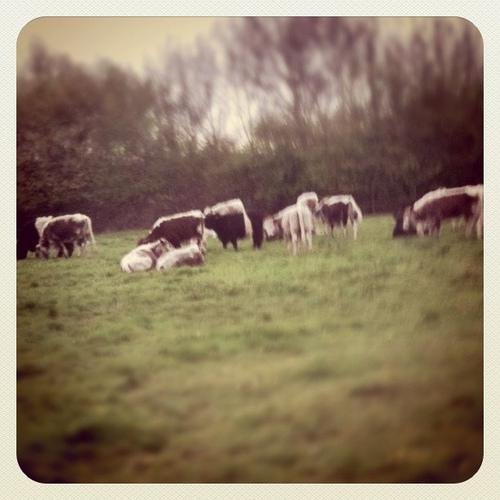Question: what is the main subject of this picture?
Choices:
A. The horses.
B. The chickens.
C. The sheep.
D. The cows.
Answer with the letter. Answer: D Question: what are the cows standing in?
Choices:
A. A field.
B. A river.
C. A park.
D. A street.
Answer with the letter. Answer: A Question: what color are most of the cows?
Choices:
A. Black.
B. Black and white.
C. Brown.
D. White and tan.
Answer with the letter. Answer: C Question: what color is the grass?
Choices:
A. Brown.
B. Gold.
C. Tan.
D. Green.
Answer with the letter. Answer: D 